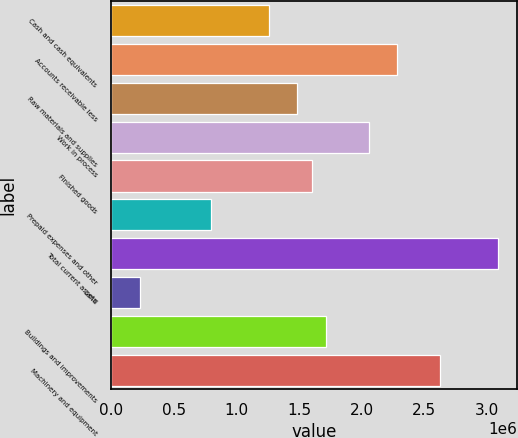<chart> <loc_0><loc_0><loc_500><loc_500><bar_chart><fcel>Cash and cash equivalents<fcel>Accounts receivable less<fcel>Raw materials and supplies<fcel>Work in process<fcel>Finished goods<fcel>Prepaid expenses and other<fcel>Total current assets<fcel>Land<fcel>Buildings and improvements<fcel>Machinery and equipment<nl><fcel>1.25677e+06<fcel>2.28489e+06<fcel>1.48524e+06<fcel>2.05642e+06<fcel>1.59948e+06<fcel>799829<fcel>3.08454e+06<fcel>228650<fcel>1.71371e+06<fcel>2.6276e+06<nl></chart> 